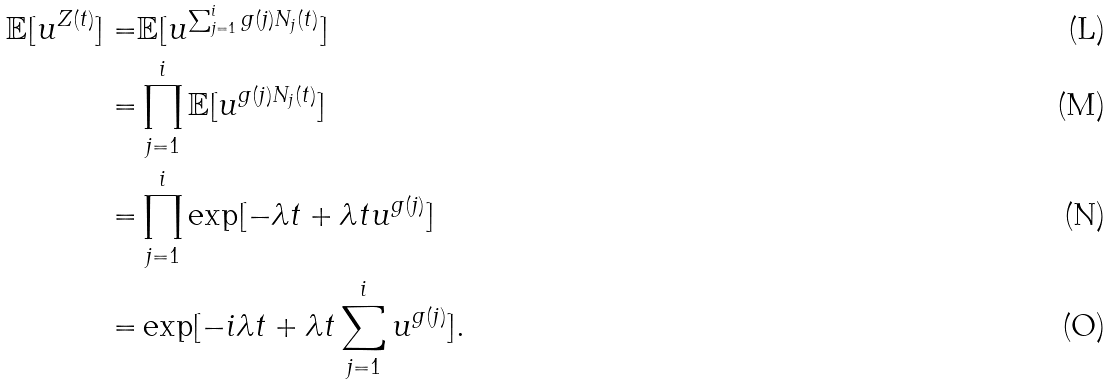Convert formula to latex. <formula><loc_0><loc_0><loc_500><loc_500>\mathbb { E } [ u ^ { Z ( t ) } ] = & \mathbb { E } [ u ^ { \sum _ { j = 1 } ^ { i } g ( j ) N _ { j } ( t ) } ] \\ = & \prod _ { j = 1 } ^ { i } \mathbb { E } [ u ^ { g ( j ) N _ { j } ( t ) } ] \\ = & \prod _ { j = 1 } ^ { i } \exp [ - \lambda t + \lambda t u ^ { g ( j ) } ] \\ = & \exp [ - i \lambda t + \lambda t \sum _ { j = 1 } ^ { i } u ^ { g ( j ) } ] .</formula> 